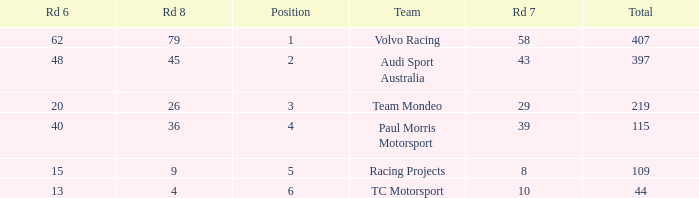What is the sum of values of Rd 7 with RD 6 less than 48 and Rd 8 less than 4 for TC Motorsport in a position greater than 1? None. 